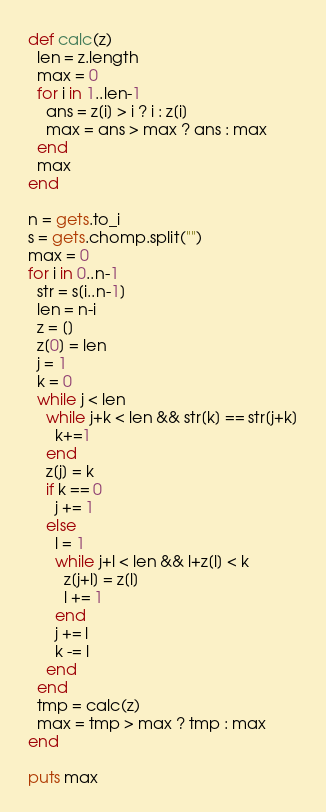Convert code to text. <code><loc_0><loc_0><loc_500><loc_500><_Ruby_>def calc(z)
  len = z.length
  max = 0
  for i in 1..len-1
    ans = z[i] > i ? i : z[i]
    max = ans > max ? ans : max
  end
  max
end

n = gets.to_i
s = gets.chomp.split("")
max = 0
for i in 0..n-1
  str = s[i..n-1]
  len = n-i
  z = []
  z[0] = len
  j = 1
  k = 0
  while j < len
    while j+k < len && str[k] == str[j+k]
      k+=1
    end
    z[j] = k
    if k == 0
      j += 1
    else
      l = 1
      while j+l < len && l+z[l] < k
        z[j+l] = z[l]
        l += 1
      end
      j += l
      k -= l
    end
  end
  tmp = calc(z)
  max = tmp > max ? tmp : max
end

puts max
</code> 